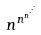<formula> <loc_0><loc_0><loc_500><loc_500>n ^ { n ^ { n ^ { \cdot ^ { \cdot ^ { \cdot } } } } }</formula> 